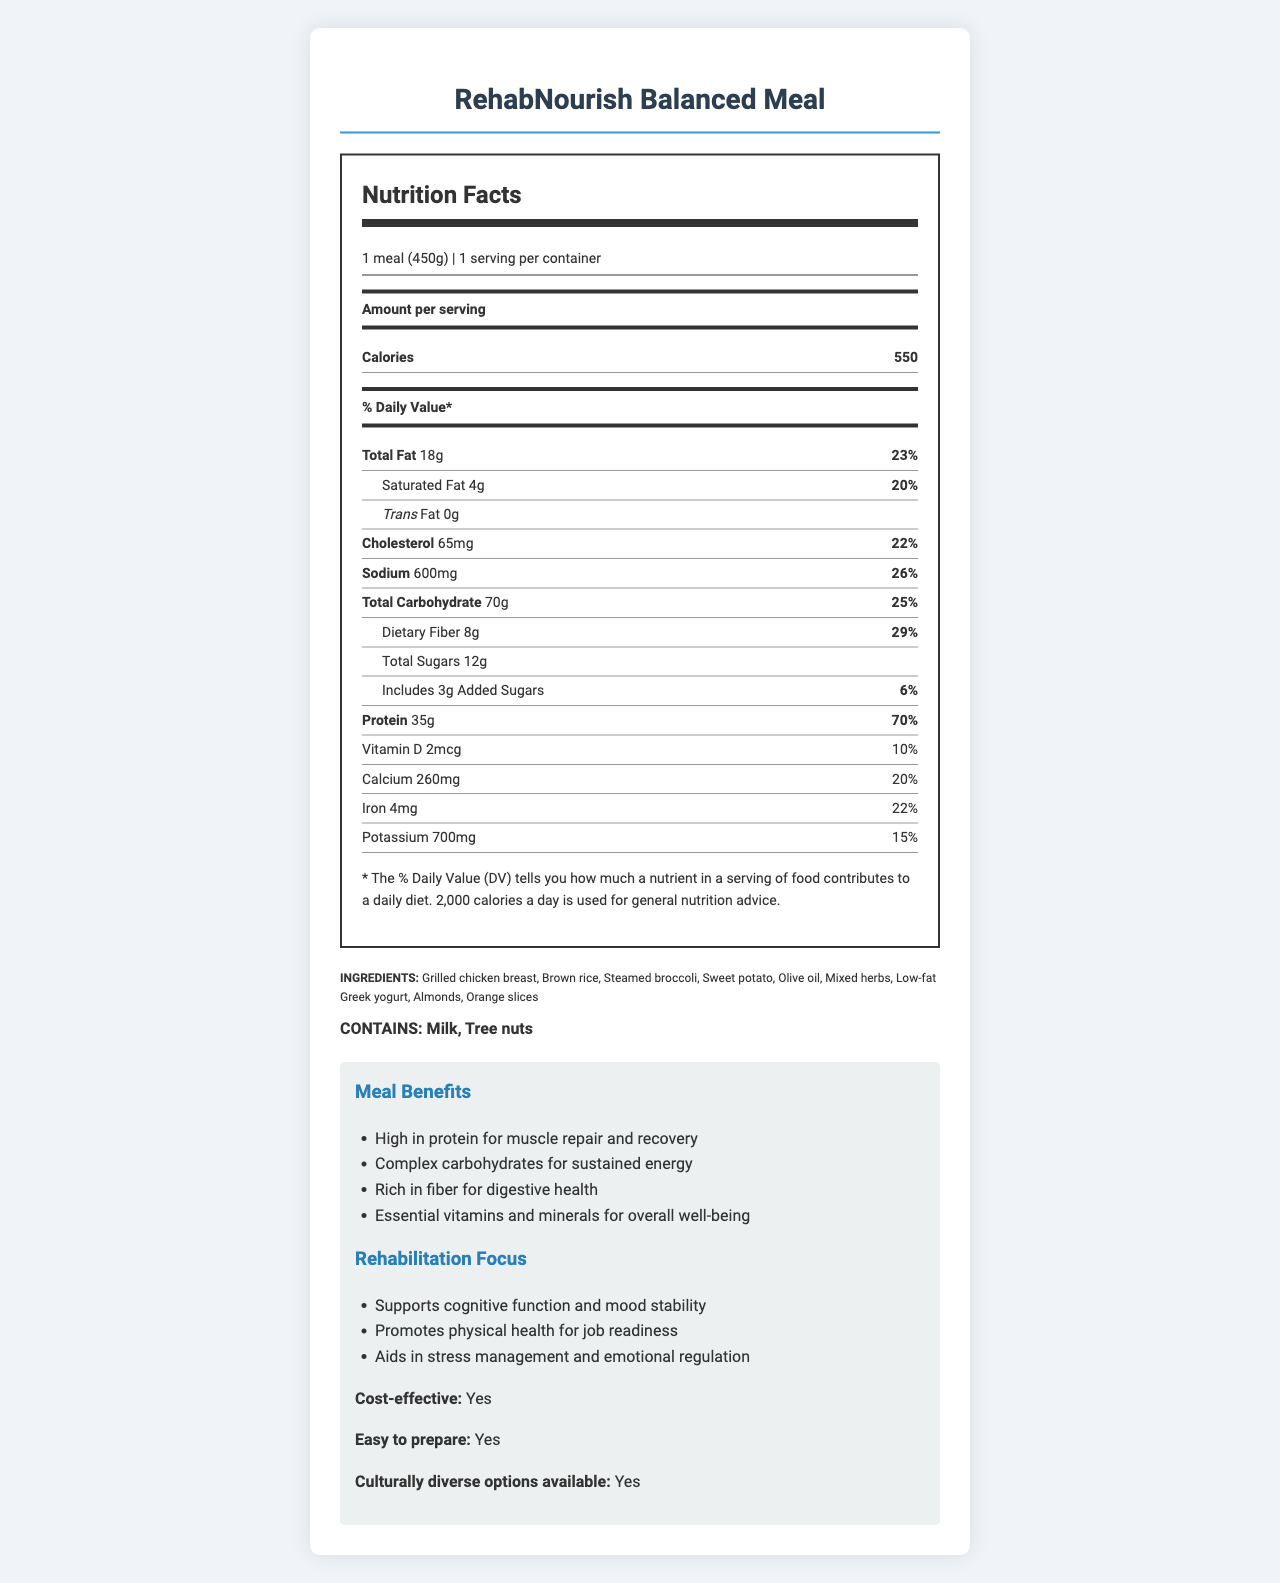what is the serving size of RehabNourish Balanced Meal? According to the document, the serving size is listed as "1 meal (450g)".
Answer: 1 meal (450g) how many calories does one serving of RehabNourish Balanced Meal contain? The document specifies that there are 550 calories per serving.
Answer: 550 what percentage of the daily value for saturated fat is provided in this meal? The document shows that the meal contains 4g of saturated fat, which corresponds to 20% of the daily value.
Answer: 20% list two ingredients in the RehabNourish Balanced Meal. The first two ingredients listed in the document are "Grilled chicken breast" and "Brown rice".
Answer: Grilled chicken breast, Brown rice how much dietary fiber does one meal contain? The nutritional facts indicate that one meal contains 8g of dietary fiber.
Answer: 8g what is the daily value percentage for cholesterol in this meal? The document states that the meal provides 22% of the daily value for cholesterol (65mg).
Answer: 22% how much iron does the RehabNourish Balanced Meal provide? A. 3mg B. 4mg C. 5mg D. 6mg The document specifies that the meal contains 4mg of iron.
Answer: B. 4mg which of the following is a benefit of the meal according to the additional information section? A. Supports weight loss B. High in protein for muscle repair and recovery C. Rich in vitamin C D. Allergy-friendly The additional information section lists "High in protein for muscle repair and recovery" as a benefit of the meal.
Answer: B. High in protein for muscle repair and recovery does the meal contain any trans fat? The document specifies that the meal contains 0g of trans fat.
Answer: No summarize the main idea of the document. The document provides various details about the meal, including nutritional facts, benefits, ingredients, allergens, and additional information aimed at supporting the rehabilitation process for parolees.
Answer: The RehabNourish Balanced Meal is a nutritional meal designed for parolees in rehabilitation programs, providing detailed nutritional information, benefits for physical and mental health, cost-effectiveness, easy preparation, and noting the ingredients and potential allergens. is the sodium content high in this meal? The sodium content is 600mg, which is 26% of the daily value, indicating a relatively high sodium content.
Answer: Yes what is the main ingredient contributing to the high protein content in the meal? Given the ingredients list, grilled chicken breast is likely the primary contributor to the high protein content of 35g per serving.
Answer: Grilled chicken breast is there information on how to prepare the meal? The document indicates that the meal is "easy to prepare," but it does not provide specific preparation instructions.
Answer: No what is the target audience for the meal plan according to the program notes? The document notes that the meal plan is designed for parolees on rehabilitation programs.
Answer: Parolees on rehabilitation programs how many meals are recommended per day in the program notes? The program notes include a recommendation for "3 balanced meals per day."
Answer: 3 balanced meals per day do the success metrics show improved physical health among the participants? The success metrics indicate that 85% of parolees report increased energy levels, showing improved physical health.
Answer: Yes is the meal cost-effective according to the document? The document explicitly mentions that the meal is cost-effective.
Answer: Yes what type of fruits are included in the RehabNourish Balanced Meal? The ingredients list includes orange slices as the fruit component of the meal.
Answer: Orange slices does the meal support job readiness? The rehabilitation focus section mentions that the meal promotes physical health for job readiness.
Answer: Yes can you determine if this meal is gluten-free based on the provided information? The document does not specify whether the meal is gluten-free.
Answer: Cannot be determined 